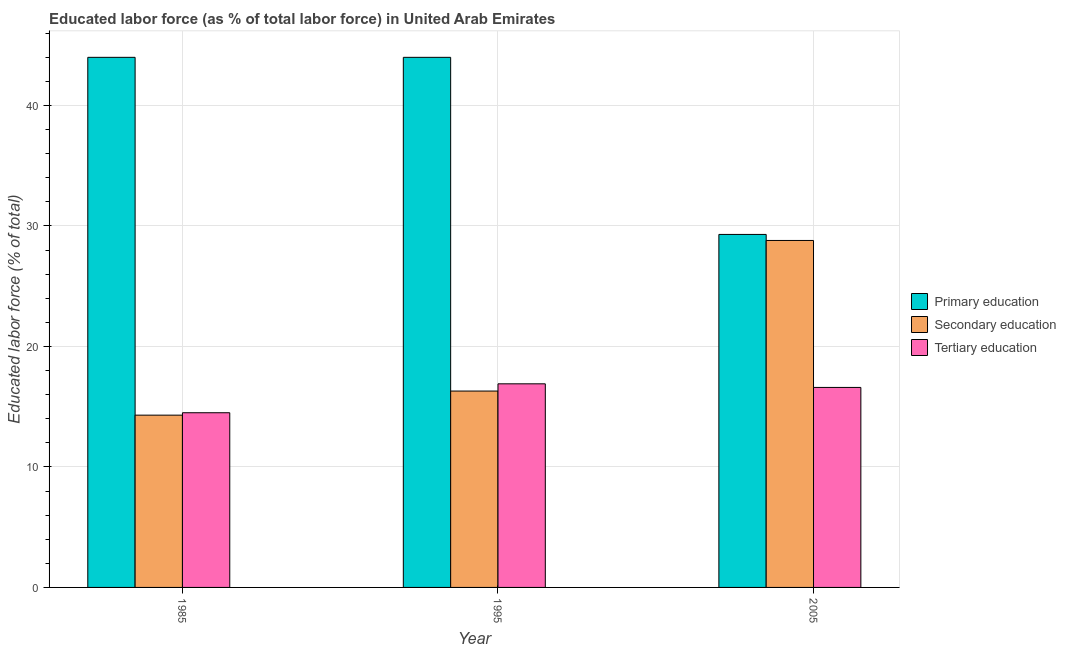Are the number of bars on each tick of the X-axis equal?
Your response must be concise. Yes. How many bars are there on the 2nd tick from the right?
Offer a terse response. 3. What is the label of the 3rd group of bars from the left?
Your answer should be compact. 2005. What is the percentage of labor force who received tertiary education in 1995?
Your response must be concise. 16.9. Across all years, what is the minimum percentage of labor force who received secondary education?
Provide a short and direct response. 14.3. In which year was the percentage of labor force who received tertiary education minimum?
Make the answer very short. 1985. What is the total percentage of labor force who received secondary education in the graph?
Your response must be concise. 59.4. What is the difference between the percentage of labor force who received tertiary education in 1985 and that in 2005?
Your answer should be very brief. -2.1. What is the difference between the percentage of labor force who received primary education in 1985 and the percentage of labor force who received secondary education in 1995?
Your answer should be very brief. 0. What is the average percentage of labor force who received secondary education per year?
Offer a terse response. 19.8. In how many years, is the percentage of labor force who received tertiary education greater than 6 %?
Ensure brevity in your answer.  3. What is the ratio of the percentage of labor force who received tertiary education in 1985 to that in 2005?
Ensure brevity in your answer.  0.87. Is the percentage of labor force who received secondary education in 1985 less than that in 1995?
Give a very brief answer. Yes. What is the difference between the highest and the second highest percentage of labor force who received tertiary education?
Provide a short and direct response. 0.3. What is the difference between the highest and the lowest percentage of labor force who received secondary education?
Provide a short and direct response. 14.5. What does the 2nd bar from the left in 1985 represents?
Your answer should be very brief. Secondary education. What does the 2nd bar from the right in 2005 represents?
Give a very brief answer. Secondary education. How many years are there in the graph?
Make the answer very short. 3. Does the graph contain any zero values?
Provide a succinct answer. No. Does the graph contain grids?
Keep it short and to the point. Yes. How many legend labels are there?
Offer a terse response. 3. What is the title of the graph?
Offer a very short reply. Educated labor force (as % of total labor force) in United Arab Emirates. What is the label or title of the X-axis?
Make the answer very short. Year. What is the label or title of the Y-axis?
Offer a very short reply. Educated labor force (% of total). What is the Educated labor force (% of total) of Secondary education in 1985?
Your answer should be very brief. 14.3. What is the Educated labor force (% of total) in Tertiary education in 1985?
Offer a very short reply. 14.5. What is the Educated labor force (% of total) of Secondary education in 1995?
Make the answer very short. 16.3. What is the Educated labor force (% of total) of Tertiary education in 1995?
Give a very brief answer. 16.9. What is the Educated labor force (% of total) of Primary education in 2005?
Give a very brief answer. 29.3. What is the Educated labor force (% of total) in Secondary education in 2005?
Give a very brief answer. 28.8. What is the Educated labor force (% of total) in Tertiary education in 2005?
Give a very brief answer. 16.6. Across all years, what is the maximum Educated labor force (% of total) in Secondary education?
Give a very brief answer. 28.8. Across all years, what is the maximum Educated labor force (% of total) of Tertiary education?
Make the answer very short. 16.9. Across all years, what is the minimum Educated labor force (% of total) of Primary education?
Your answer should be very brief. 29.3. Across all years, what is the minimum Educated labor force (% of total) in Secondary education?
Provide a short and direct response. 14.3. Across all years, what is the minimum Educated labor force (% of total) in Tertiary education?
Offer a very short reply. 14.5. What is the total Educated labor force (% of total) of Primary education in the graph?
Make the answer very short. 117.3. What is the total Educated labor force (% of total) of Secondary education in the graph?
Provide a short and direct response. 59.4. What is the total Educated labor force (% of total) of Tertiary education in the graph?
Ensure brevity in your answer.  48. What is the difference between the Educated labor force (% of total) of Tertiary education in 1985 and that in 1995?
Make the answer very short. -2.4. What is the difference between the Educated labor force (% of total) in Primary education in 1985 and that in 2005?
Your answer should be very brief. 14.7. What is the difference between the Educated labor force (% of total) of Primary education in 1985 and the Educated labor force (% of total) of Secondary education in 1995?
Offer a terse response. 27.7. What is the difference between the Educated labor force (% of total) in Primary education in 1985 and the Educated labor force (% of total) in Tertiary education in 1995?
Ensure brevity in your answer.  27.1. What is the difference between the Educated labor force (% of total) of Secondary education in 1985 and the Educated labor force (% of total) of Tertiary education in 1995?
Offer a very short reply. -2.6. What is the difference between the Educated labor force (% of total) of Primary education in 1985 and the Educated labor force (% of total) of Secondary education in 2005?
Make the answer very short. 15.2. What is the difference between the Educated labor force (% of total) in Primary education in 1985 and the Educated labor force (% of total) in Tertiary education in 2005?
Ensure brevity in your answer.  27.4. What is the difference between the Educated labor force (% of total) of Primary education in 1995 and the Educated labor force (% of total) of Tertiary education in 2005?
Provide a short and direct response. 27.4. What is the average Educated labor force (% of total) of Primary education per year?
Offer a very short reply. 39.1. What is the average Educated labor force (% of total) in Secondary education per year?
Provide a short and direct response. 19.8. In the year 1985, what is the difference between the Educated labor force (% of total) of Primary education and Educated labor force (% of total) of Secondary education?
Offer a very short reply. 29.7. In the year 1985, what is the difference between the Educated labor force (% of total) in Primary education and Educated labor force (% of total) in Tertiary education?
Your answer should be very brief. 29.5. In the year 1995, what is the difference between the Educated labor force (% of total) in Primary education and Educated labor force (% of total) in Secondary education?
Ensure brevity in your answer.  27.7. In the year 1995, what is the difference between the Educated labor force (% of total) of Primary education and Educated labor force (% of total) of Tertiary education?
Provide a succinct answer. 27.1. In the year 1995, what is the difference between the Educated labor force (% of total) of Secondary education and Educated labor force (% of total) of Tertiary education?
Provide a succinct answer. -0.6. What is the ratio of the Educated labor force (% of total) in Primary education in 1985 to that in 1995?
Your answer should be compact. 1. What is the ratio of the Educated labor force (% of total) of Secondary education in 1985 to that in 1995?
Your response must be concise. 0.88. What is the ratio of the Educated labor force (% of total) in Tertiary education in 1985 to that in 1995?
Offer a very short reply. 0.86. What is the ratio of the Educated labor force (% of total) in Primary education in 1985 to that in 2005?
Your answer should be very brief. 1.5. What is the ratio of the Educated labor force (% of total) in Secondary education in 1985 to that in 2005?
Your response must be concise. 0.5. What is the ratio of the Educated labor force (% of total) in Tertiary education in 1985 to that in 2005?
Your response must be concise. 0.87. What is the ratio of the Educated labor force (% of total) of Primary education in 1995 to that in 2005?
Your response must be concise. 1.5. What is the ratio of the Educated labor force (% of total) in Secondary education in 1995 to that in 2005?
Your answer should be very brief. 0.57. What is the ratio of the Educated labor force (% of total) of Tertiary education in 1995 to that in 2005?
Your response must be concise. 1.02. What is the difference between the highest and the second highest Educated labor force (% of total) in Primary education?
Keep it short and to the point. 0. 